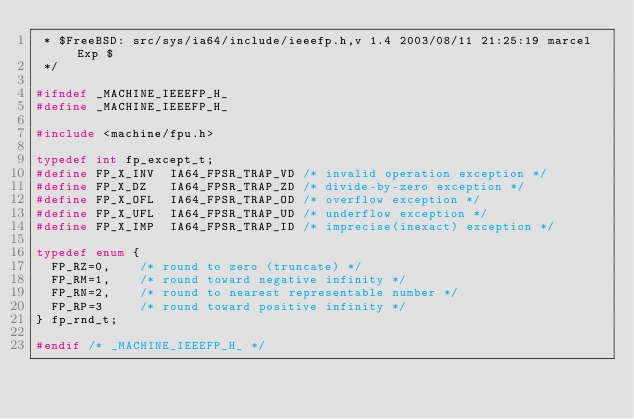<code> <loc_0><loc_0><loc_500><loc_500><_C_> * $FreeBSD: src/sys/ia64/include/ieeefp.h,v 1.4 2003/08/11 21:25:19 marcel Exp $
 */

#ifndef _MACHINE_IEEEFP_H_
#define _MACHINE_IEEEFP_H_

#include <machine/fpu.h>

typedef int fp_except_t;
#define	FP_X_INV	IA64_FPSR_TRAP_VD /* invalid operation exception */
#define	FP_X_DZ		IA64_FPSR_TRAP_ZD /* divide-by-zero exception */
#define	FP_X_OFL	IA64_FPSR_TRAP_OD /* overflow exception */
#define	FP_X_UFL	IA64_FPSR_TRAP_UD /* underflow exception */
#define	FP_X_IMP	IA64_FPSR_TRAP_ID /* imprecise(inexact) exception */

typedef enum {
	FP_RZ=0,		/* round to zero (truncate) */
	FP_RM=1,		/* round toward negative infinity */
	FP_RN=2,		/* round to nearest representable number */
	FP_RP=3			/* round toward positive infinity */
} fp_rnd_t;

#endif /* _MACHINE_IEEEFP_H_ */
</code> 